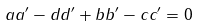<formula> <loc_0><loc_0><loc_500><loc_500>a a ^ { \prime } - d d ^ { \prime } + b b ^ { \prime } - c c ^ { \prime } = 0</formula> 